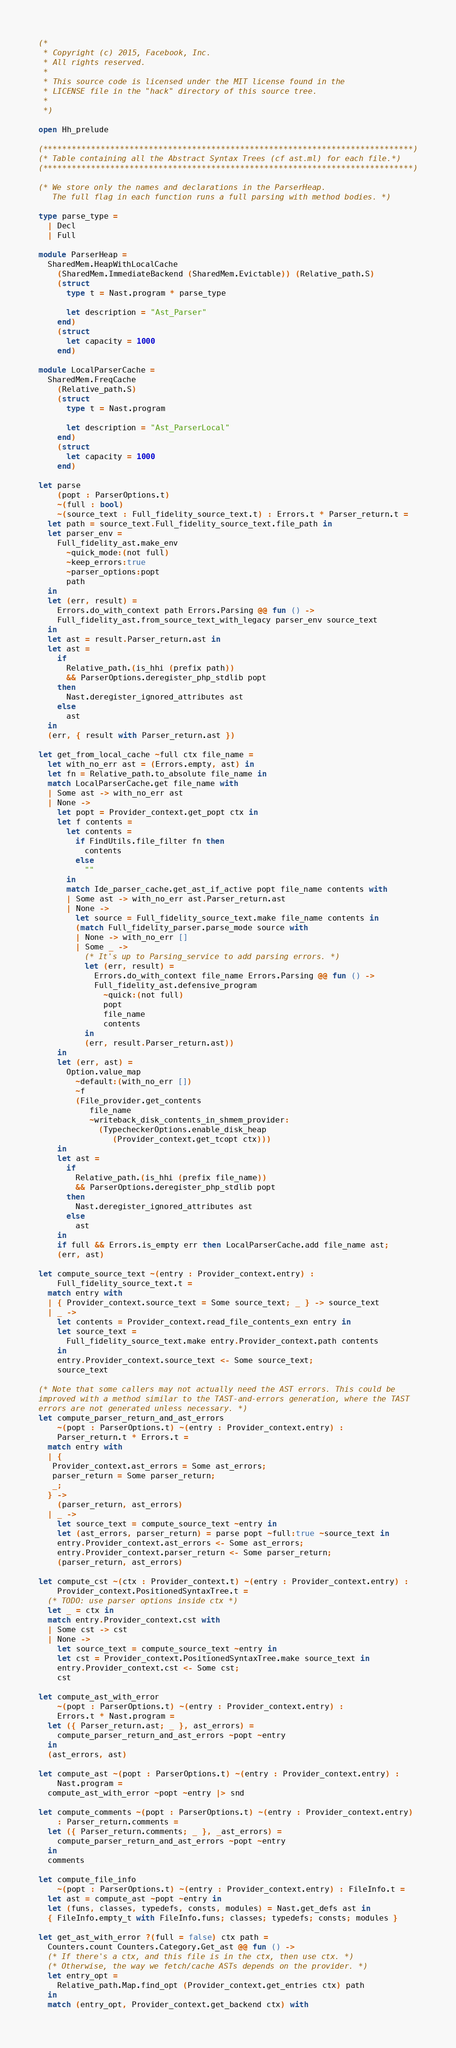<code> <loc_0><loc_0><loc_500><loc_500><_OCaml_>(*
 * Copyright (c) 2015, Facebook, Inc.
 * All rights reserved.
 *
 * This source code is licensed under the MIT license found in the
 * LICENSE file in the "hack" directory of this source tree.
 *
 *)

open Hh_prelude

(*****************************************************************************)
(* Table containing all the Abstract Syntax Trees (cf ast.ml) for each file.*)
(*****************************************************************************)

(* We store only the names and declarations in the ParserHeap.
   The full flag in each function runs a full parsing with method bodies. *)

type parse_type =
  | Decl
  | Full

module ParserHeap =
  SharedMem.HeapWithLocalCache
    (SharedMem.ImmediateBackend (SharedMem.Evictable)) (Relative_path.S)
    (struct
      type t = Nast.program * parse_type

      let description = "Ast_Parser"
    end)
    (struct
      let capacity = 1000
    end)

module LocalParserCache =
  SharedMem.FreqCache
    (Relative_path.S)
    (struct
      type t = Nast.program

      let description = "Ast_ParserLocal"
    end)
    (struct
      let capacity = 1000
    end)

let parse
    (popt : ParserOptions.t)
    ~(full : bool)
    ~(source_text : Full_fidelity_source_text.t) : Errors.t * Parser_return.t =
  let path = source_text.Full_fidelity_source_text.file_path in
  let parser_env =
    Full_fidelity_ast.make_env
      ~quick_mode:(not full)
      ~keep_errors:true
      ~parser_options:popt
      path
  in
  let (err, result) =
    Errors.do_with_context path Errors.Parsing @@ fun () ->
    Full_fidelity_ast.from_source_text_with_legacy parser_env source_text
  in
  let ast = result.Parser_return.ast in
  let ast =
    if
      Relative_path.(is_hhi (prefix path))
      && ParserOptions.deregister_php_stdlib popt
    then
      Nast.deregister_ignored_attributes ast
    else
      ast
  in
  (err, { result with Parser_return.ast })

let get_from_local_cache ~full ctx file_name =
  let with_no_err ast = (Errors.empty, ast) in
  let fn = Relative_path.to_absolute file_name in
  match LocalParserCache.get file_name with
  | Some ast -> with_no_err ast
  | None ->
    let popt = Provider_context.get_popt ctx in
    let f contents =
      let contents =
        if FindUtils.file_filter fn then
          contents
        else
          ""
      in
      match Ide_parser_cache.get_ast_if_active popt file_name contents with
      | Some ast -> with_no_err ast.Parser_return.ast
      | None ->
        let source = Full_fidelity_source_text.make file_name contents in
        (match Full_fidelity_parser.parse_mode source with
        | None -> with_no_err []
        | Some _ ->
          (* It's up to Parsing_service to add parsing errors. *)
          let (err, result) =
            Errors.do_with_context file_name Errors.Parsing @@ fun () ->
            Full_fidelity_ast.defensive_program
              ~quick:(not full)
              popt
              file_name
              contents
          in
          (err, result.Parser_return.ast))
    in
    let (err, ast) =
      Option.value_map
        ~default:(with_no_err [])
        ~f
        (File_provider.get_contents
           file_name
           ~writeback_disk_contents_in_shmem_provider:
             (TypecheckerOptions.enable_disk_heap
                (Provider_context.get_tcopt ctx)))
    in
    let ast =
      if
        Relative_path.(is_hhi (prefix file_name))
        && ParserOptions.deregister_php_stdlib popt
      then
        Nast.deregister_ignored_attributes ast
      else
        ast
    in
    if full && Errors.is_empty err then LocalParserCache.add file_name ast;
    (err, ast)

let compute_source_text ~(entry : Provider_context.entry) :
    Full_fidelity_source_text.t =
  match entry with
  | { Provider_context.source_text = Some source_text; _ } -> source_text
  | _ ->
    let contents = Provider_context.read_file_contents_exn entry in
    let source_text =
      Full_fidelity_source_text.make entry.Provider_context.path contents
    in
    entry.Provider_context.source_text <- Some source_text;
    source_text

(* Note that some callers may not actually need the AST errors. This could be
improved with a method similar to the TAST-and-errors generation, where the TAST
errors are not generated unless necessary. *)
let compute_parser_return_and_ast_errors
    ~(popt : ParserOptions.t) ~(entry : Provider_context.entry) :
    Parser_return.t * Errors.t =
  match entry with
  | {
   Provider_context.ast_errors = Some ast_errors;
   parser_return = Some parser_return;
   _;
  } ->
    (parser_return, ast_errors)
  | _ ->
    let source_text = compute_source_text ~entry in
    let (ast_errors, parser_return) = parse popt ~full:true ~source_text in
    entry.Provider_context.ast_errors <- Some ast_errors;
    entry.Provider_context.parser_return <- Some parser_return;
    (parser_return, ast_errors)

let compute_cst ~(ctx : Provider_context.t) ~(entry : Provider_context.entry) :
    Provider_context.PositionedSyntaxTree.t =
  (* TODO: use parser options inside ctx *)
  let _ = ctx in
  match entry.Provider_context.cst with
  | Some cst -> cst
  | None ->
    let source_text = compute_source_text ~entry in
    let cst = Provider_context.PositionedSyntaxTree.make source_text in
    entry.Provider_context.cst <- Some cst;
    cst

let compute_ast_with_error
    ~(popt : ParserOptions.t) ~(entry : Provider_context.entry) :
    Errors.t * Nast.program =
  let ({ Parser_return.ast; _ }, ast_errors) =
    compute_parser_return_and_ast_errors ~popt ~entry
  in
  (ast_errors, ast)

let compute_ast ~(popt : ParserOptions.t) ~(entry : Provider_context.entry) :
    Nast.program =
  compute_ast_with_error ~popt ~entry |> snd

let compute_comments ~(popt : ParserOptions.t) ~(entry : Provider_context.entry)
    : Parser_return.comments =
  let ({ Parser_return.comments; _ }, _ast_errors) =
    compute_parser_return_and_ast_errors ~popt ~entry
  in
  comments

let compute_file_info
    ~(popt : ParserOptions.t) ~(entry : Provider_context.entry) : FileInfo.t =
  let ast = compute_ast ~popt ~entry in
  let (funs, classes, typedefs, consts, modules) = Nast.get_defs ast in
  { FileInfo.empty_t with FileInfo.funs; classes; typedefs; consts; modules }

let get_ast_with_error ?(full = false) ctx path =
  Counters.count Counters.Category.Get_ast @@ fun () ->
  (* If there's a ctx, and this file is in the ctx, then use ctx. *)
  (* Otherwise, the way we fetch/cache ASTs depends on the provider. *)
  let entry_opt =
    Relative_path.Map.find_opt (Provider_context.get_entries ctx) path
  in
  match (entry_opt, Provider_context.get_backend ctx) with</code> 